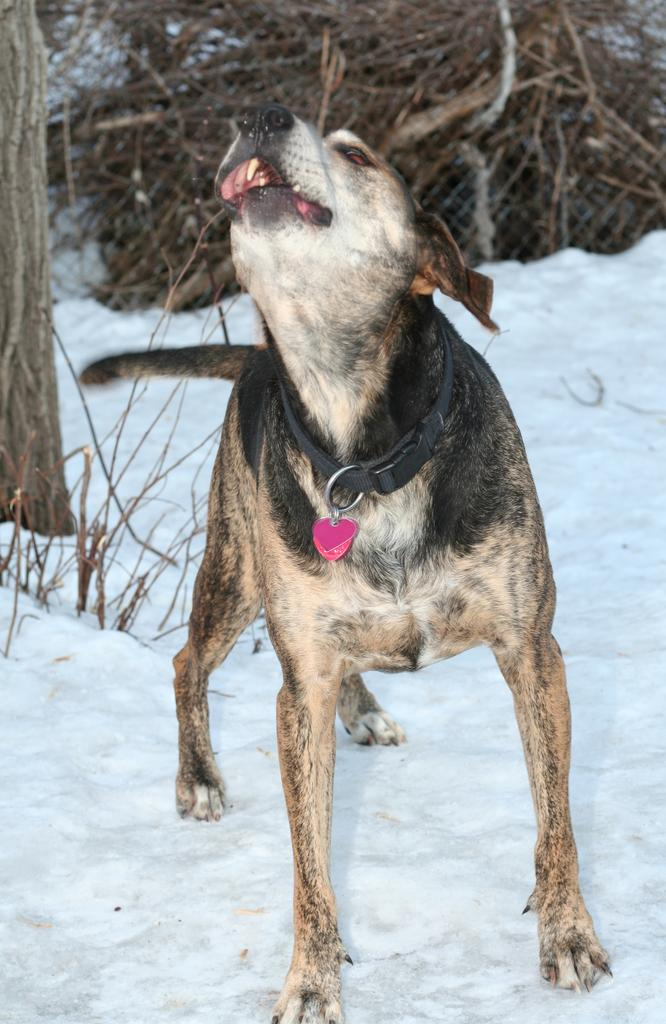What type of animal is in the picture? There is a dog in the picture. What is the dog wearing around its neck? The dog has a belt around its neck. What other object can be seen in the picture? There is a locket in the picture. What is on the left side of the image? There appears to be a tree on the left side of the image. What can be used for various purposes, such as building or starting a fire, in the image? There are sticks visible in the image. What is the ground covered with in the image? There is snow on the ground in the image. What type of cap is the dog wearing in the image? There is no cap present in the image; the dog has a belt around its neck. How many eggs are visible in the image? There are no eggs present in the image. 